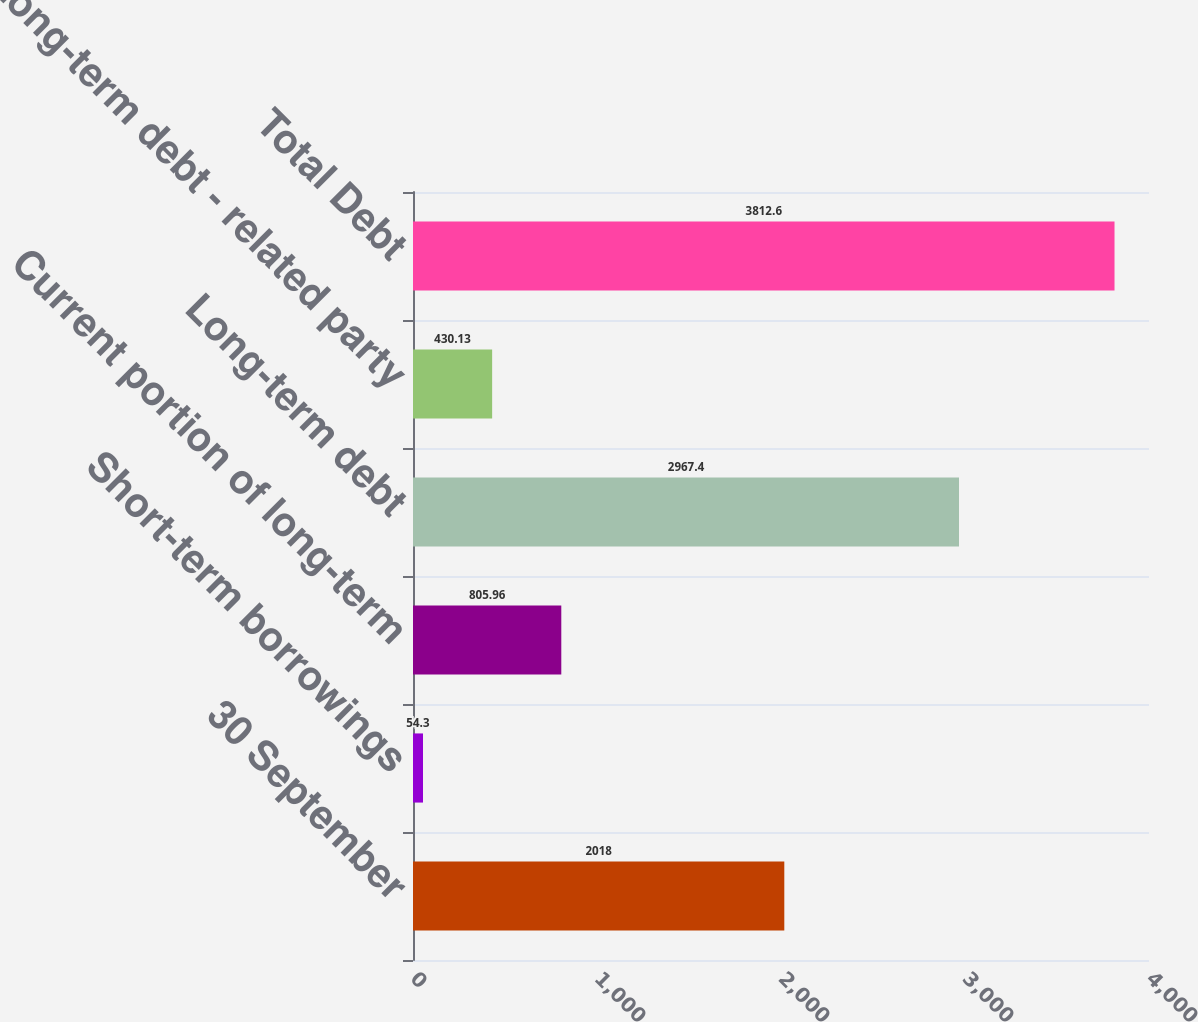Convert chart to OTSL. <chart><loc_0><loc_0><loc_500><loc_500><bar_chart><fcel>30 September<fcel>Short-term borrowings<fcel>Current portion of long-term<fcel>Long-term debt<fcel>Long-term debt - related party<fcel>Total Debt<nl><fcel>2018<fcel>54.3<fcel>805.96<fcel>2967.4<fcel>430.13<fcel>3812.6<nl></chart> 